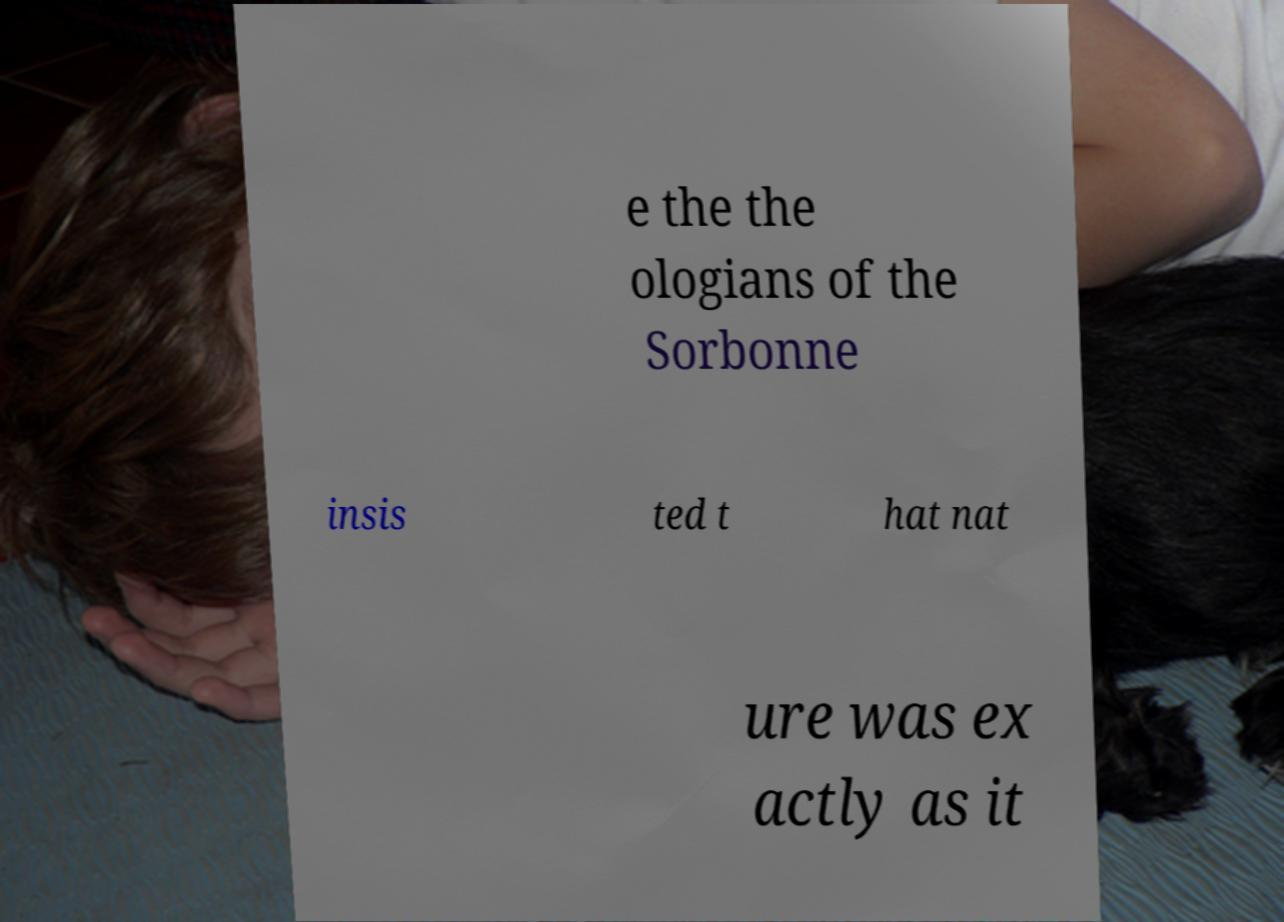What messages or text are displayed in this image? I need them in a readable, typed format. e the the ologians of the Sorbonne insis ted t hat nat ure was ex actly as it 